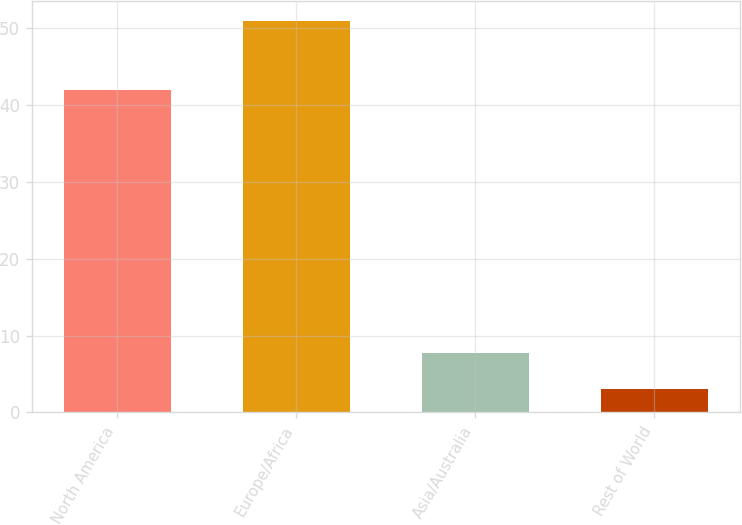Convert chart. <chart><loc_0><loc_0><loc_500><loc_500><bar_chart><fcel>North America<fcel>Europe/Africa<fcel>Asia/Australia<fcel>Rest of World<nl><fcel>42<fcel>51<fcel>7.8<fcel>3<nl></chart> 